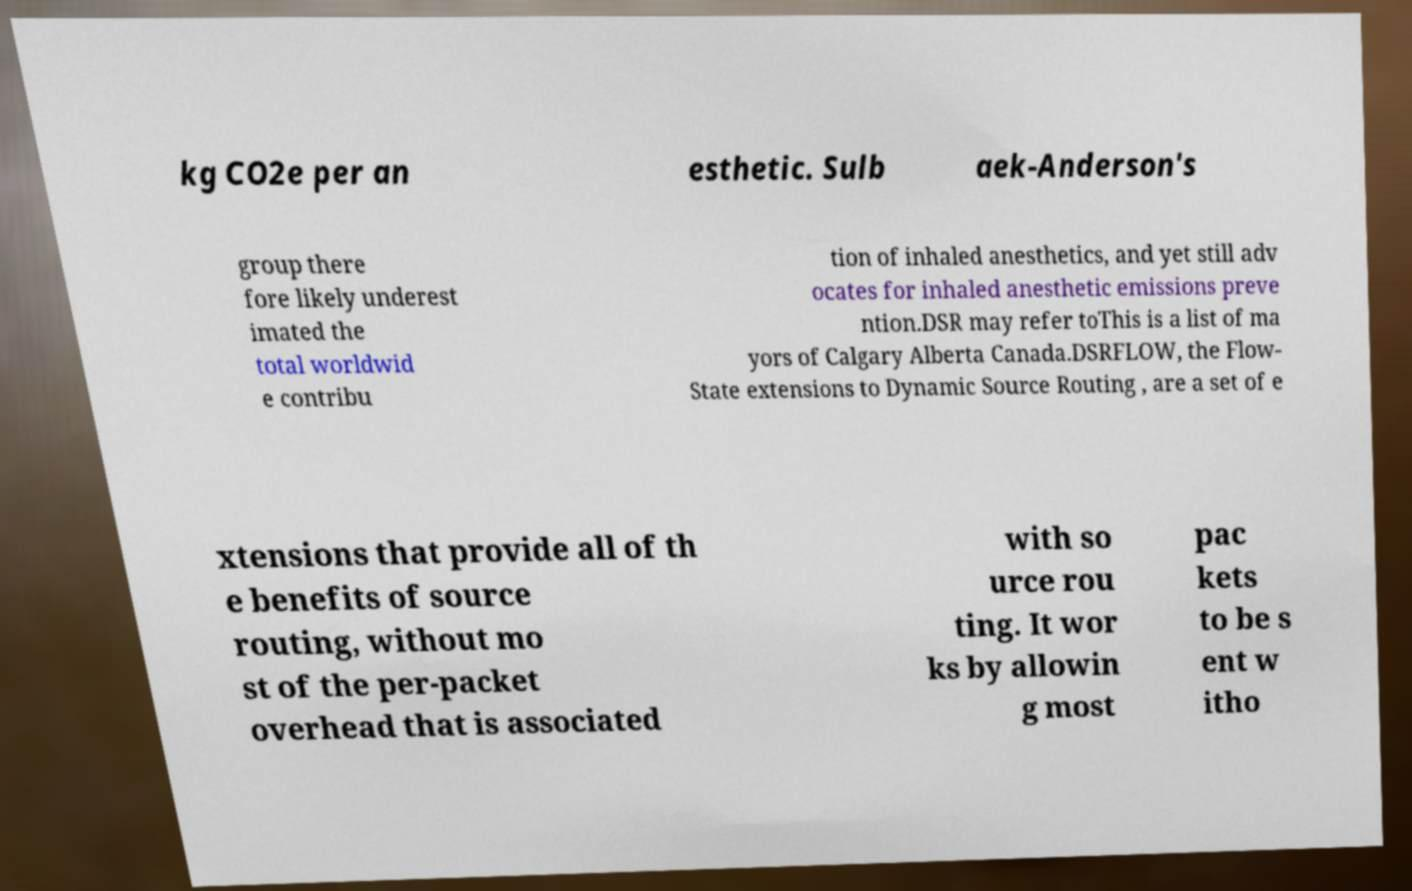Please read and relay the text visible in this image. What does it say? kg CO2e per an esthetic. Sulb aek-Anderson's group there fore likely underest imated the total worldwid e contribu tion of inhaled anesthetics, and yet still adv ocates for inhaled anesthetic emissions preve ntion.DSR may refer toThis is a list of ma yors of Calgary Alberta Canada.DSRFLOW, the Flow- State extensions to Dynamic Source Routing , are a set of e xtensions that provide all of th e benefits of source routing, without mo st of the per-packet overhead that is associated with so urce rou ting. It wor ks by allowin g most pac kets to be s ent w itho 